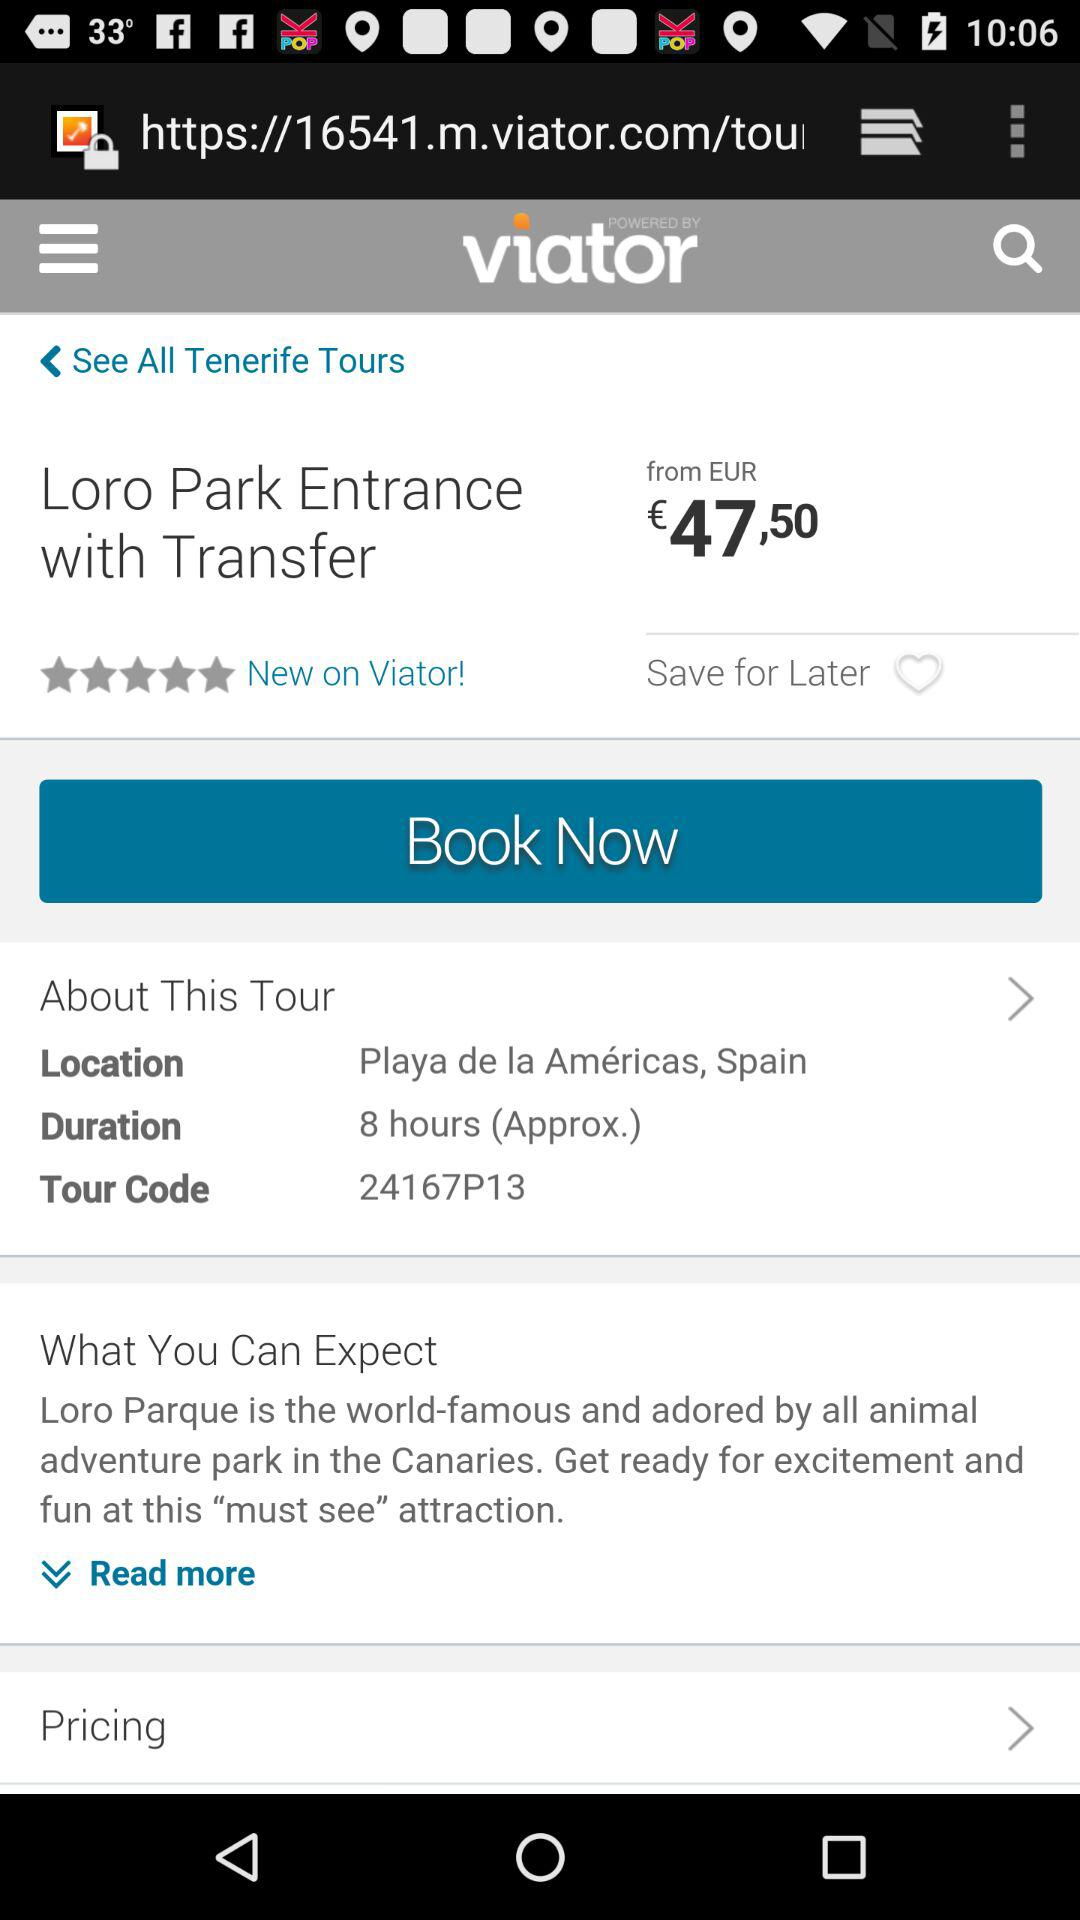What is the location of "Loro Park"? The location is Playa de las Américas, Spain. 